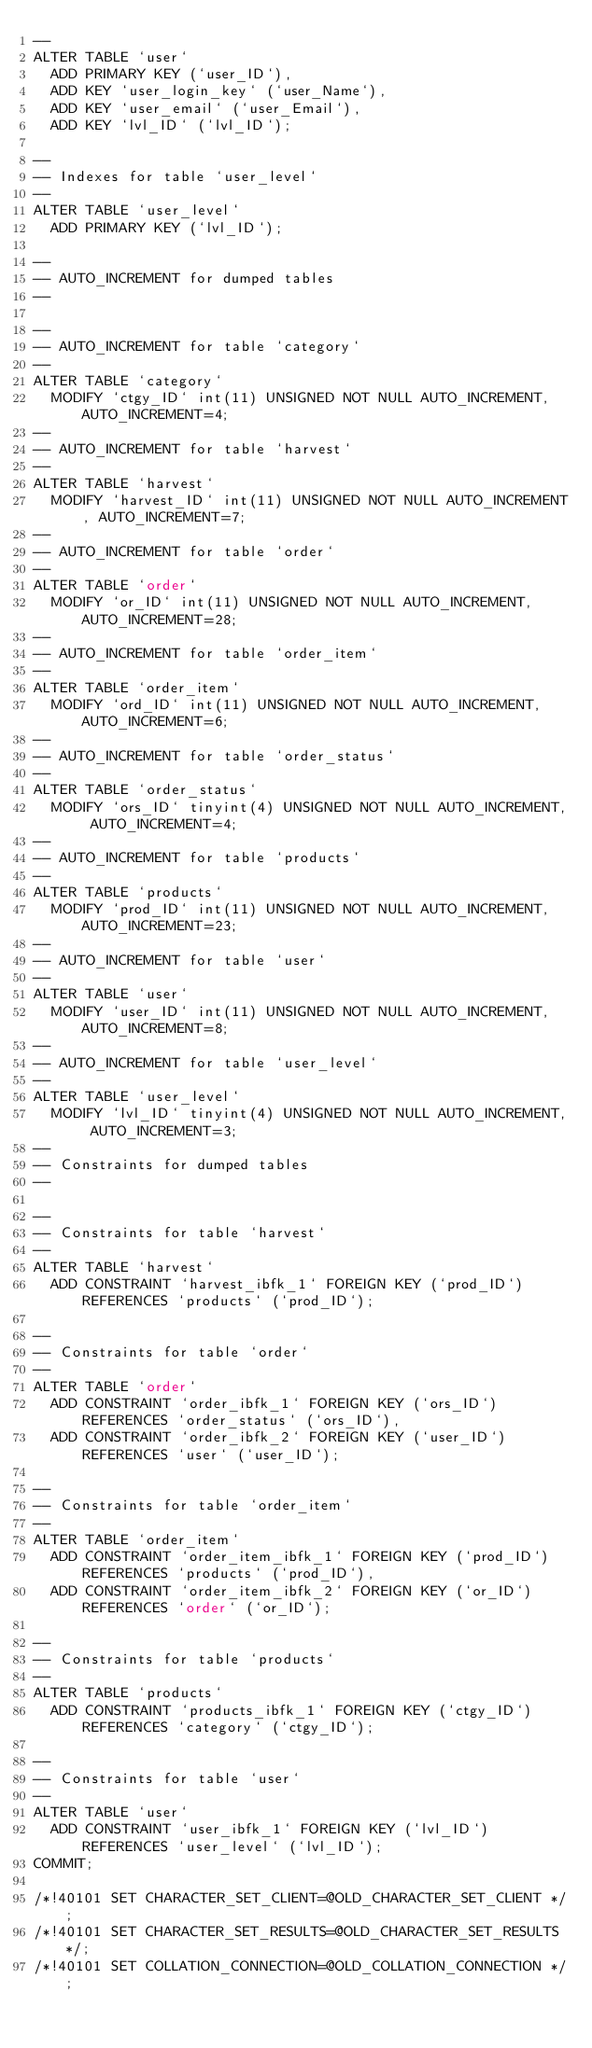<code> <loc_0><loc_0><loc_500><loc_500><_SQL_>--
ALTER TABLE `user`
  ADD PRIMARY KEY (`user_ID`),
  ADD KEY `user_login_key` (`user_Name`),
  ADD KEY `user_email` (`user_Email`),
  ADD KEY `lvl_ID` (`lvl_ID`);

--
-- Indexes for table `user_level`
--
ALTER TABLE `user_level`
  ADD PRIMARY KEY (`lvl_ID`);

--
-- AUTO_INCREMENT for dumped tables
--

--
-- AUTO_INCREMENT for table `category`
--
ALTER TABLE `category`
  MODIFY `ctgy_ID` int(11) UNSIGNED NOT NULL AUTO_INCREMENT, AUTO_INCREMENT=4;
--
-- AUTO_INCREMENT for table `harvest`
--
ALTER TABLE `harvest`
  MODIFY `harvest_ID` int(11) UNSIGNED NOT NULL AUTO_INCREMENT, AUTO_INCREMENT=7;
--
-- AUTO_INCREMENT for table `order`
--
ALTER TABLE `order`
  MODIFY `or_ID` int(11) UNSIGNED NOT NULL AUTO_INCREMENT, AUTO_INCREMENT=28;
--
-- AUTO_INCREMENT for table `order_item`
--
ALTER TABLE `order_item`
  MODIFY `ord_ID` int(11) UNSIGNED NOT NULL AUTO_INCREMENT, AUTO_INCREMENT=6;
--
-- AUTO_INCREMENT for table `order_status`
--
ALTER TABLE `order_status`
  MODIFY `ors_ID` tinyint(4) UNSIGNED NOT NULL AUTO_INCREMENT, AUTO_INCREMENT=4;
--
-- AUTO_INCREMENT for table `products`
--
ALTER TABLE `products`
  MODIFY `prod_ID` int(11) UNSIGNED NOT NULL AUTO_INCREMENT, AUTO_INCREMENT=23;
--
-- AUTO_INCREMENT for table `user`
--
ALTER TABLE `user`
  MODIFY `user_ID` int(11) UNSIGNED NOT NULL AUTO_INCREMENT, AUTO_INCREMENT=8;
--
-- AUTO_INCREMENT for table `user_level`
--
ALTER TABLE `user_level`
  MODIFY `lvl_ID` tinyint(4) UNSIGNED NOT NULL AUTO_INCREMENT, AUTO_INCREMENT=3;
--
-- Constraints for dumped tables
--

--
-- Constraints for table `harvest`
--
ALTER TABLE `harvest`
  ADD CONSTRAINT `harvest_ibfk_1` FOREIGN KEY (`prod_ID`) REFERENCES `products` (`prod_ID`);

--
-- Constraints for table `order`
--
ALTER TABLE `order`
  ADD CONSTRAINT `order_ibfk_1` FOREIGN KEY (`ors_ID`) REFERENCES `order_status` (`ors_ID`),
  ADD CONSTRAINT `order_ibfk_2` FOREIGN KEY (`user_ID`) REFERENCES `user` (`user_ID`);

--
-- Constraints for table `order_item`
--
ALTER TABLE `order_item`
  ADD CONSTRAINT `order_item_ibfk_1` FOREIGN KEY (`prod_ID`) REFERENCES `products` (`prod_ID`),
  ADD CONSTRAINT `order_item_ibfk_2` FOREIGN KEY (`or_ID`) REFERENCES `order` (`or_ID`);

--
-- Constraints for table `products`
--
ALTER TABLE `products`
  ADD CONSTRAINT `products_ibfk_1` FOREIGN KEY (`ctgy_ID`) REFERENCES `category` (`ctgy_ID`);

--
-- Constraints for table `user`
--
ALTER TABLE `user`
  ADD CONSTRAINT `user_ibfk_1` FOREIGN KEY (`lvl_ID`) REFERENCES `user_level` (`lvl_ID`);
COMMIT;

/*!40101 SET CHARACTER_SET_CLIENT=@OLD_CHARACTER_SET_CLIENT */;
/*!40101 SET CHARACTER_SET_RESULTS=@OLD_CHARACTER_SET_RESULTS */;
/*!40101 SET COLLATION_CONNECTION=@OLD_COLLATION_CONNECTION */;
</code> 